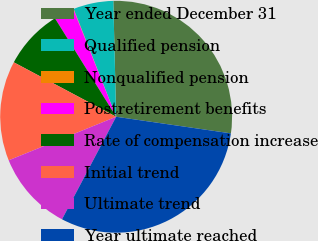<chart> <loc_0><loc_0><loc_500><loc_500><pie_chart><fcel>Year ended December 31<fcel>Qualified pension<fcel>Nonqualified pension<fcel>Postretirement benefits<fcel>Rate of compensation increase<fcel>Initial trend<fcel>Ultimate trend<fcel>Year ultimate reached<nl><fcel>27.68%<fcel>5.59%<fcel>0.05%<fcel>2.82%<fcel>8.37%<fcel>13.91%<fcel>11.14%<fcel>30.45%<nl></chart> 